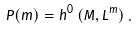Convert formula to latex. <formula><loc_0><loc_0><loc_500><loc_500>P ( m ) = h ^ { 0 } \left ( M , L ^ { m } \right ) .</formula> 